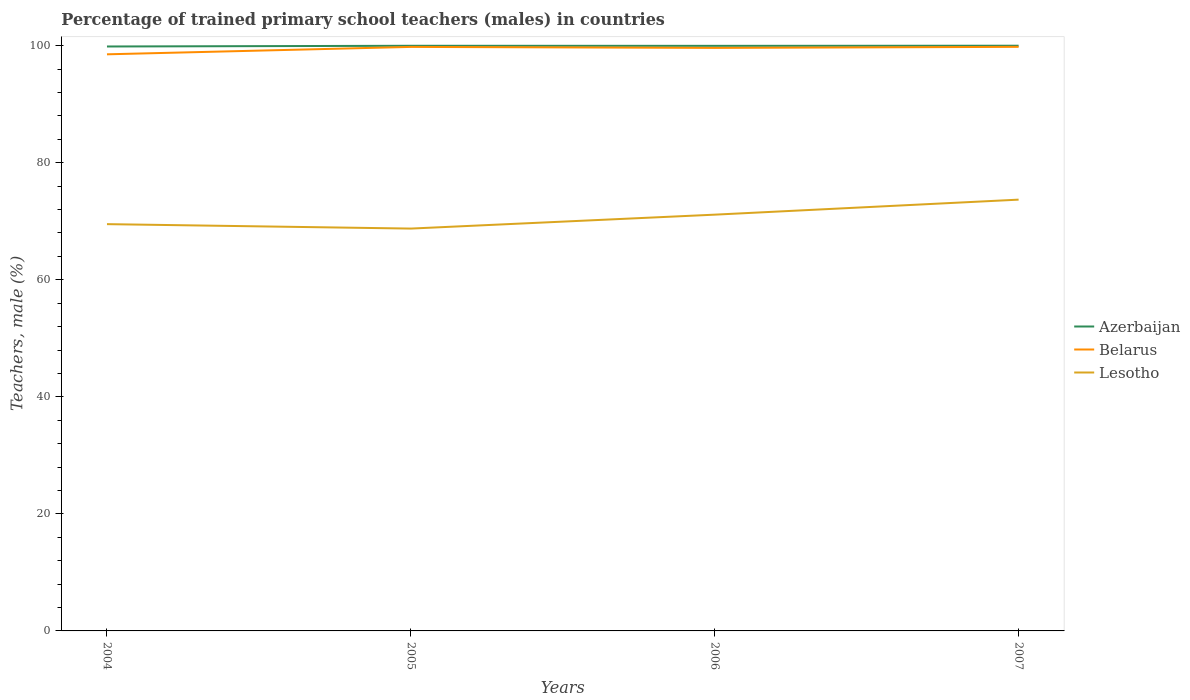Does the line corresponding to Lesotho intersect with the line corresponding to Azerbaijan?
Give a very brief answer. No. Across all years, what is the maximum percentage of trained primary school teachers (males) in Lesotho?
Provide a succinct answer. 68.75. In which year was the percentage of trained primary school teachers (males) in Azerbaijan maximum?
Your answer should be compact. 2004. What is the total percentage of trained primary school teachers (males) in Lesotho in the graph?
Your answer should be very brief. -1.62. What is the difference between the highest and the second highest percentage of trained primary school teachers (males) in Belarus?
Your response must be concise. 1.28. Is the percentage of trained primary school teachers (males) in Belarus strictly greater than the percentage of trained primary school teachers (males) in Lesotho over the years?
Offer a very short reply. No. How many lines are there?
Provide a short and direct response. 3. What is the difference between two consecutive major ticks on the Y-axis?
Your answer should be compact. 20. Are the values on the major ticks of Y-axis written in scientific E-notation?
Your answer should be compact. No. Does the graph contain grids?
Give a very brief answer. No. Where does the legend appear in the graph?
Offer a very short reply. Center right. How are the legend labels stacked?
Provide a short and direct response. Vertical. What is the title of the graph?
Make the answer very short. Percentage of trained primary school teachers (males) in countries. Does "Europe(all income levels)" appear as one of the legend labels in the graph?
Your answer should be compact. No. What is the label or title of the X-axis?
Ensure brevity in your answer.  Years. What is the label or title of the Y-axis?
Offer a terse response. Teachers, male (%). What is the Teachers, male (%) in Azerbaijan in 2004?
Keep it short and to the point. 99.87. What is the Teachers, male (%) of Belarus in 2004?
Ensure brevity in your answer.  98.53. What is the Teachers, male (%) in Lesotho in 2004?
Offer a very short reply. 69.51. What is the Teachers, male (%) in Azerbaijan in 2005?
Your answer should be very brief. 99.99. What is the Teachers, male (%) of Belarus in 2005?
Make the answer very short. 99.8. What is the Teachers, male (%) in Lesotho in 2005?
Keep it short and to the point. 68.75. What is the Teachers, male (%) in Azerbaijan in 2006?
Your answer should be very brief. 99.98. What is the Teachers, male (%) in Belarus in 2006?
Offer a terse response. 99.63. What is the Teachers, male (%) of Lesotho in 2006?
Your answer should be very brief. 71.13. What is the Teachers, male (%) of Azerbaijan in 2007?
Offer a very short reply. 100. What is the Teachers, male (%) of Belarus in 2007?
Offer a very short reply. 99.81. What is the Teachers, male (%) of Lesotho in 2007?
Give a very brief answer. 73.7. Across all years, what is the maximum Teachers, male (%) of Azerbaijan?
Keep it short and to the point. 100. Across all years, what is the maximum Teachers, male (%) in Belarus?
Keep it short and to the point. 99.81. Across all years, what is the maximum Teachers, male (%) of Lesotho?
Offer a very short reply. 73.7. Across all years, what is the minimum Teachers, male (%) in Azerbaijan?
Make the answer very short. 99.87. Across all years, what is the minimum Teachers, male (%) in Belarus?
Keep it short and to the point. 98.53. Across all years, what is the minimum Teachers, male (%) of Lesotho?
Your response must be concise. 68.75. What is the total Teachers, male (%) in Azerbaijan in the graph?
Make the answer very short. 399.84. What is the total Teachers, male (%) in Belarus in the graph?
Give a very brief answer. 397.76. What is the total Teachers, male (%) in Lesotho in the graph?
Keep it short and to the point. 283.09. What is the difference between the Teachers, male (%) in Azerbaijan in 2004 and that in 2005?
Ensure brevity in your answer.  -0.12. What is the difference between the Teachers, male (%) in Belarus in 2004 and that in 2005?
Provide a short and direct response. -1.26. What is the difference between the Teachers, male (%) of Lesotho in 2004 and that in 2005?
Offer a very short reply. 0.76. What is the difference between the Teachers, male (%) in Azerbaijan in 2004 and that in 2006?
Make the answer very short. -0.11. What is the difference between the Teachers, male (%) of Belarus in 2004 and that in 2006?
Your answer should be compact. -1.1. What is the difference between the Teachers, male (%) of Lesotho in 2004 and that in 2006?
Offer a very short reply. -1.62. What is the difference between the Teachers, male (%) of Azerbaijan in 2004 and that in 2007?
Offer a very short reply. -0.13. What is the difference between the Teachers, male (%) of Belarus in 2004 and that in 2007?
Your response must be concise. -1.28. What is the difference between the Teachers, male (%) of Lesotho in 2004 and that in 2007?
Provide a short and direct response. -4.19. What is the difference between the Teachers, male (%) of Azerbaijan in 2005 and that in 2006?
Provide a short and direct response. 0.01. What is the difference between the Teachers, male (%) in Belarus in 2005 and that in 2006?
Your answer should be compact. 0.17. What is the difference between the Teachers, male (%) in Lesotho in 2005 and that in 2006?
Ensure brevity in your answer.  -2.38. What is the difference between the Teachers, male (%) of Azerbaijan in 2005 and that in 2007?
Give a very brief answer. -0.01. What is the difference between the Teachers, male (%) in Belarus in 2005 and that in 2007?
Ensure brevity in your answer.  -0.01. What is the difference between the Teachers, male (%) of Lesotho in 2005 and that in 2007?
Make the answer very short. -4.94. What is the difference between the Teachers, male (%) in Azerbaijan in 2006 and that in 2007?
Provide a short and direct response. -0.02. What is the difference between the Teachers, male (%) of Belarus in 2006 and that in 2007?
Keep it short and to the point. -0.18. What is the difference between the Teachers, male (%) in Lesotho in 2006 and that in 2007?
Provide a short and direct response. -2.56. What is the difference between the Teachers, male (%) in Azerbaijan in 2004 and the Teachers, male (%) in Belarus in 2005?
Offer a terse response. 0.07. What is the difference between the Teachers, male (%) in Azerbaijan in 2004 and the Teachers, male (%) in Lesotho in 2005?
Provide a short and direct response. 31.12. What is the difference between the Teachers, male (%) of Belarus in 2004 and the Teachers, male (%) of Lesotho in 2005?
Provide a short and direct response. 29.78. What is the difference between the Teachers, male (%) of Azerbaijan in 2004 and the Teachers, male (%) of Belarus in 2006?
Offer a terse response. 0.24. What is the difference between the Teachers, male (%) of Azerbaijan in 2004 and the Teachers, male (%) of Lesotho in 2006?
Give a very brief answer. 28.74. What is the difference between the Teachers, male (%) of Belarus in 2004 and the Teachers, male (%) of Lesotho in 2006?
Provide a succinct answer. 27.4. What is the difference between the Teachers, male (%) of Azerbaijan in 2004 and the Teachers, male (%) of Belarus in 2007?
Provide a succinct answer. 0.06. What is the difference between the Teachers, male (%) of Azerbaijan in 2004 and the Teachers, male (%) of Lesotho in 2007?
Offer a terse response. 26.17. What is the difference between the Teachers, male (%) of Belarus in 2004 and the Teachers, male (%) of Lesotho in 2007?
Keep it short and to the point. 24.83. What is the difference between the Teachers, male (%) of Azerbaijan in 2005 and the Teachers, male (%) of Belarus in 2006?
Provide a short and direct response. 0.36. What is the difference between the Teachers, male (%) in Azerbaijan in 2005 and the Teachers, male (%) in Lesotho in 2006?
Offer a very short reply. 28.86. What is the difference between the Teachers, male (%) of Belarus in 2005 and the Teachers, male (%) of Lesotho in 2006?
Give a very brief answer. 28.66. What is the difference between the Teachers, male (%) in Azerbaijan in 2005 and the Teachers, male (%) in Belarus in 2007?
Provide a short and direct response. 0.18. What is the difference between the Teachers, male (%) in Azerbaijan in 2005 and the Teachers, male (%) in Lesotho in 2007?
Your answer should be compact. 26.29. What is the difference between the Teachers, male (%) of Belarus in 2005 and the Teachers, male (%) of Lesotho in 2007?
Offer a terse response. 26.1. What is the difference between the Teachers, male (%) in Azerbaijan in 2006 and the Teachers, male (%) in Belarus in 2007?
Offer a terse response. 0.17. What is the difference between the Teachers, male (%) of Azerbaijan in 2006 and the Teachers, male (%) of Lesotho in 2007?
Your answer should be very brief. 26.28. What is the difference between the Teachers, male (%) of Belarus in 2006 and the Teachers, male (%) of Lesotho in 2007?
Your answer should be very brief. 25.93. What is the average Teachers, male (%) in Azerbaijan per year?
Offer a terse response. 99.96. What is the average Teachers, male (%) of Belarus per year?
Provide a short and direct response. 99.44. What is the average Teachers, male (%) in Lesotho per year?
Ensure brevity in your answer.  70.77. In the year 2004, what is the difference between the Teachers, male (%) in Azerbaijan and Teachers, male (%) in Belarus?
Provide a succinct answer. 1.34. In the year 2004, what is the difference between the Teachers, male (%) of Azerbaijan and Teachers, male (%) of Lesotho?
Provide a short and direct response. 30.36. In the year 2004, what is the difference between the Teachers, male (%) in Belarus and Teachers, male (%) in Lesotho?
Your answer should be very brief. 29.02. In the year 2005, what is the difference between the Teachers, male (%) in Azerbaijan and Teachers, male (%) in Belarus?
Your response must be concise. 0.19. In the year 2005, what is the difference between the Teachers, male (%) of Azerbaijan and Teachers, male (%) of Lesotho?
Provide a succinct answer. 31.24. In the year 2005, what is the difference between the Teachers, male (%) of Belarus and Teachers, male (%) of Lesotho?
Ensure brevity in your answer.  31.04. In the year 2006, what is the difference between the Teachers, male (%) of Azerbaijan and Teachers, male (%) of Belarus?
Offer a terse response. 0.35. In the year 2006, what is the difference between the Teachers, male (%) of Azerbaijan and Teachers, male (%) of Lesotho?
Offer a very short reply. 28.85. In the year 2006, what is the difference between the Teachers, male (%) in Belarus and Teachers, male (%) in Lesotho?
Provide a succinct answer. 28.49. In the year 2007, what is the difference between the Teachers, male (%) of Azerbaijan and Teachers, male (%) of Belarus?
Keep it short and to the point. 0.19. In the year 2007, what is the difference between the Teachers, male (%) in Azerbaijan and Teachers, male (%) in Lesotho?
Your answer should be compact. 26.3. In the year 2007, what is the difference between the Teachers, male (%) of Belarus and Teachers, male (%) of Lesotho?
Provide a succinct answer. 26.11. What is the ratio of the Teachers, male (%) of Belarus in 2004 to that in 2005?
Offer a very short reply. 0.99. What is the ratio of the Teachers, male (%) in Lesotho in 2004 to that in 2006?
Provide a succinct answer. 0.98. What is the ratio of the Teachers, male (%) in Belarus in 2004 to that in 2007?
Keep it short and to the point. 0.99. What is the ratio of the Teachers, male (%) of Lesotho in 2004 to that in 2007?
Your response must be concise. 0.94. What is the ratio of the Teachers, male (%) of Belarus in 2005 to that in 2006?
Ensure brevity in your answer.  1. What is the ratio of the Teachers, male (%) in Lesotho in 2005 to that in 2006?
Your response must be concise. 0.97. What is the ratio of the Teachers, male (%) of Belarus in 2005 to that in 2007?
Your response must be concise. 1. What is the ratio of the Teachers, male (%) of Lesotho in 2005 to that in 2007?
Provide a short and direct response. 0.93. What is the ratio of the Teachers, male (%) of Azerbaijan in 2006 to that in 2007?
Ensure brevity in your answer.  1. What is the ratio of the Teachers, male (%) in Belarus in 2006 to that in 2007?
Provide a short and direct response. 1. What is the ratio of the Teachers, male (%) in Lesotho in 2006 to that in 2007?
Your response must be concise. 0.97. What is the difference between the highest and the second highest Teachers, male (%) in Azerbaijan?
Provide a short and direct response. 0.01. What is the difference between the highest and the second highest Teachers, male (%) in Belarus?
Offer a very short reply. 0.01. What is the difference between the highest and the second highest Teachers, male (%) in Lesotho?
Your answer should be very brief. 2.56. What is the difference between the highest and the lowest Teachers, male (%) in Azerbaijan?
Give a very brief answer. 0.13. What is the difference between the highest and the lowest Teachers, male (%) in Belarus?
Keep it short and to the point. 1.28. What is the difference between the highest and the lowest Teachers, male (%) in Lesotho?
Make the answer very short. 4.94. 